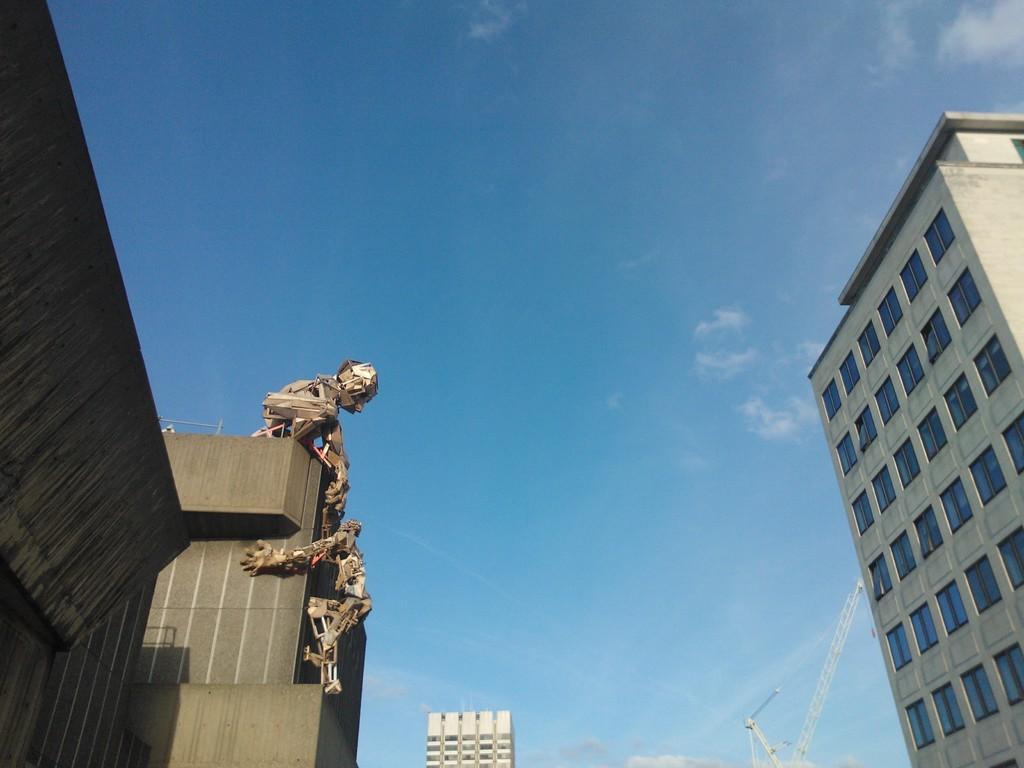Can you describe this image briefly? In this picture there are skyscrapers on the right and left side of the image. 